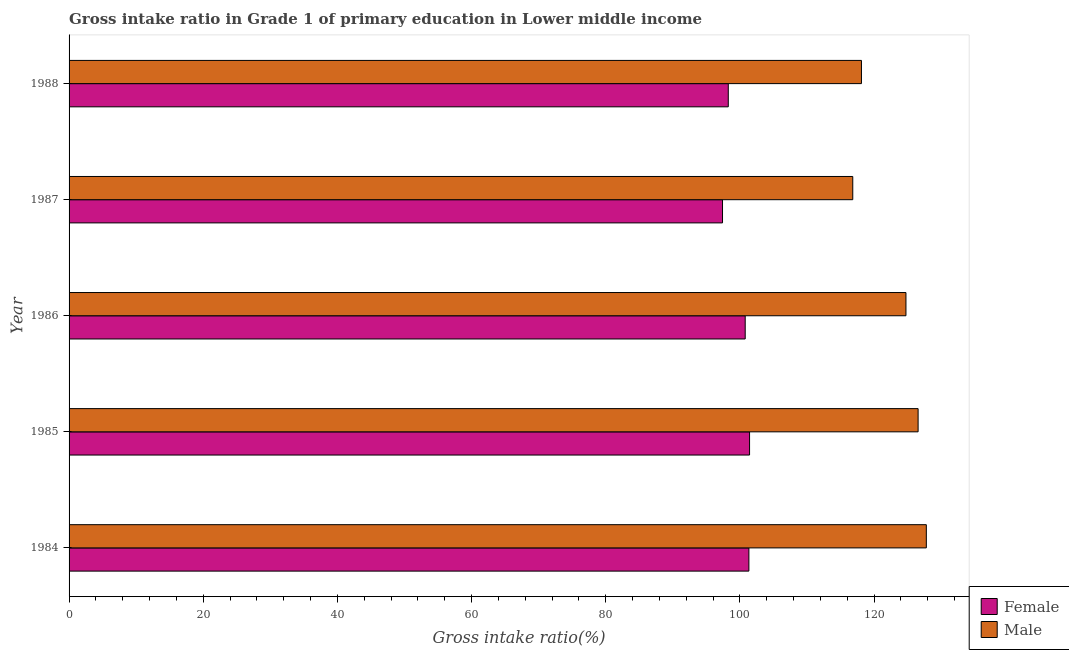How many groups of bars are there?
Keep it short and to the point. 5. Are the number of bars per tick equal to the number of legend labels?
Give a very brief answer. Yes. Are the number of bars on each tick of the Y-axis equal?
Your answer should be compact. Yes. How many bars are there on the 5th tick from the top?
Offer a terse response. 2. What is the gross intake ratio(male) in 1987?
Your answer should be compact. 116.81. Across all years, what is the maximum gross intake ratio(female)?
Make the answer very short. 101.43. Across all years, what is the minimum gross intake ratio(female)?
Your response must be concise. 97.4. In which year was the gross intake ratio(female) maximum?
Provide a succinct answer. 1985. What is the total gross intake ratio(male) in the graph?
Keep it short and to the point. 613.99. What is the difference between the gross intake ratio(female) in 1986 and that in 1987?
Your answer should be very brief. 3.38. What is the difference between the gross intake ratio(female) in 1985 and the gross intake ratio(male) in 1984?
Give a very brief answer. -26.35. What is the average gross intake ratio(male) per year?
Your response must be concise. 122.8. In the year 1988, what is the difference between the gross intake ratio(male) and gross intake ratio(female)?
Ensure brevity in your answer.  19.85. In how many years, is the gross intake ratio(female) greater than 100 %?
Your response must be concise. 3. What is the ratio of the gross intake ratio(male) in 1985 to that in 1987?
Provide a short and direct response. 1.08. Is the gross intake ratio(male) in 1984 less than that in 1988?
Provide a short and direct response. No. Is the difference between the gross intake ratio(female) in 1987 and 1988 greater than the difference between the gross intake ratio(male) in 1987 and 1988?
Provide a succinct answer. Yes. What is the difference between the highest and the second highest gross intake ratio(female)?
Provide a succinct answer. 0.1. What is the difference between the highest and the lowest gross intake ratio(female)?
Your answer should be very brief. 4.03. In how many years, is the gross intake ratio(female) greater than the average gross intake ratio(female) taken over all years?
Make the answer very short. 3. What does the 2nd bar from the top in 1986 represents?
Your response must be concise. Female. What does the 1st bar from the bottom in 1987 represents?
Ensure brevity in your answer.  Female. What is the difference between two consecutive major ticks on the X-axis?
Offer a terse response. 20. Where does the legend appear in the graph?
Give a very brief answer. Bottom right. What is the title of the graph?
Provide a succinct answer. Gross intake ratio in Grade 1 of primary education in Lower middle income. Does "Private credit bureau" appear as one of the legend labels in the graph?
Your answer should be compact. No. What is the label or title of the X-axis?
Offer a terse response. Gross intake ratio(%). What is the label or title of the Y-axis?
Keep it short and to the point. Year. What is the Gross intake ratio(%) in Female in 1984?
Give a very brief answer. 101.33. What is the Gross intake ratio(%) of Male in 1984?
Keep it short and to the point. 127.78. What is the Gross intake ratio(%) of Female in 1985?
Make the answer very short. 101.43. What is the Gross intake ratio(%) in Male in 1985?
Provide a short and direct response. 126.55. What is the Gross intake ratio(%) of Female in 1986?
Your answer should be very brief. 100.78. What is the Gross intake ratio(%) in Male in 1986?
Make the answer very short. 124.74. What is the Gross intake ratio(%) of Female in 1987?
Your answer should be compact. 97.4. What is the Gross intake ratio(%) in Male in 1987?
Your response must be concise. 116.81. What is the Gross intake ratio(%) of Female in 1988?
Offer a terse response. 98.26. What is the Gross intake ratio(%) in Male in 1988?
Give a very brief answer. 118.11. Across all years, what is the maximum Gross intake ratio(%) of Female?
Give a very brief answer. 101.43. Across all years, what is the maximum Gross intake ratio(%) of Male?
Offer a very short reply. 127.78. Across all years, what is the minimum Gross intake ratio(%) in Female?
Offer a terse response. 97.4. Across all years, what is the minimum Gross intake ratio(%) of Male?
Give a very brief answer. 116.81. What is the total Gross intake ratio(%) of Female in the graph?
Provide a succinct answer. 499.19. What is the total Gross intake ratio(%) in Male in the graph?
Offer a very short reply. 613.99. What is the difference between the Gross intake ratio(%) in Female in 1984 and that in 1985?
Your answer should be compact. -0.1. What is the difference between the Gross intake ratio(%) of Male in 1984 and that in 1985?
Give a very brief answer. 1.23. What is the difference between the Gross intake ratio(%) of Female in 1984 and that in 1986?
Ensure brevity in your answer.  0.55. What is the difference between the Gross intake ratio(%) in Male in 1984 and that in 1986?
Your response must be concise. 3.04. What is the difference between the Gross intake ratio(%) of Female in 1984 and that in 1987?
Provide a short and direct response. 3.93. What is the difference between the Gross intake ratio(%) in Male in 1984 and that in 1987?
Ensure brevity in your answer.  10.97. What is the difference between the Gross intake ratio(%) in Female in 1984 and that in 1988?
Provide a short and direct response. 3.07. What is the difference between the Gross intake ratio(%) in Male in 1984 and that in 1988?
Your response must be concise. 9.67. What is the difference between the Gross intake ratio(%) in Female in 1985 and that in 1986?
Provide a short and direct response. 0.65. What is the difference between the Gross intake ratio(%) of Male in 1985 and that in 1986?
Make the answer very short. 1.81. What is the difference between the Gross intake ratio(%) in Female in 1985 and that in 1987?
Provide a short and direct response. 4.03. What is the difference between the Gross intake ratio(%) of Male in 1985 and that in 1987?
Offer a very short reply. 9.74. What is the difference between the Gross intake ratio(%) in Female in 1985 and that in 1988?
Make the answer very short. 3.17. What is the difference between the Gross intake ratio(%) of Male in 1985 and that in 1988?
Offer a very short reply. 8.45. What is the difference between the Gross intake ratio(%) of Female in 1986 and that in 1987?
Ensure brevity in your answer.  3.38. What is the difference between the Gross intake ratio(%) of Male in 1986 and that in 1987?
Keep it short and to the point. 7.93. What is the difference between the Gross intake ratio(%) in Female in 1986 and that in 1988?
Provide a succinct answer. 2.52. What is the difference between the Gross intake ratio(%) of Male in 1986 and that in 1988?
Your answer should be very brief. 6.63. What is the difference between the Gross intake ratio(%) in Female in 1987 and that in 1988?
Give a very brief answer. -0.86. What is the difference between the Gross intake ratio(%) in Male in 1987 and that in 1988?
Provide a short and direct response. -1.29. What is the difference between the Gross intake ratio(%) in Female in 1984 and the Gross intake ratio(%) in Male in 1985?
Make the answer very short. -25.22. What is the difference between the Gross intake ratio(%) of Female in 1984 and the Gross intake ratio(%) of Male in 1986?
Ensure brevity in your answer.  -23.41. What is the difference between the Gross intake ratio(%) of Female in 1984 and the Gross intake ratio(%) of Male in 1987?
Offer a terse response. -15.48. What is the difference between the Gross intake ratio(%) in Female in 1984 and the Gross intake ratio(%) in Male in 1988?
Provide a succinct answer. -16.78. What is the difference between the Gross intake ratio(%) in Female in 1985 and the Gross intake ratio(%) in Male in 1986?
Your answer should be very brief. -23.31. What is the difference between the Gross intake ratio(%) in Female in 1985 and the Gross intake ratio(%) in Male in 1987?
Offer a terse response. -15.38. What is the difference between the Gross intake ratio(%) of Female in 1985 and the Gross intake ratio(%) of Male in 1988?
Your response must be concise. -16.68. What is the difference between the Gross intake ratio(%) of Female in 1986 and the Gross intake ratio(%) of Male in 1987?
Provide a succinct answer. -16.03. What is the difference between the Gross intake ratio(%) in Female in 1986 and the Gross intake ratio(%) in Male in 1988?
Offer a very short reply. -17.33. What is the difference between the Gross intake ratio(%) of Female in 1987 and the Gross intake ratio(%) of Male in 1988?
Offer a very short reply. -20.71. What is the average Gross intake ratio(%) in Female per year?
Give a very brief answer. 99.84. What is the average Gross intake ratio(%) of Male per year?
Offer a terse response. 122.8. In the year 1984, what is the difference between the Gross intake ratio(%) in Female and Gross intake ratio(%) in Male?
Provide a short and direct response. -26.45. In the year 1985, what is the difference between the Gross intake ratio(%) in Female and Gross intake ratio(%) in Male?
Your answer should be compact. -25.12. In the year 1986, what is the difference between the Gross intake ratio(%) of Female and Gross intake ratio(%) of Male?
Your response must be concise. -23.96. In the year 1987, what is the difference between the Gross intake ratio(%) of Female and Gross intake ratio(%) of Male?
Make the answer very short. -19.41. In the year 1988, what is the difference between the Gross intake ratio(%) of Female and Gross intake ratio(%) of Male?
Ensure brevity in your answer.  -19.85. What is the ratio of the Gross intake ratio(%) in Male in 1984 to that in 1985?
Keep it short and to the point. 1.01. What is the ratio of the Gross intake ratio(%) of Female in 1984 to that in 1986?
Your answer should be very brief. 1.01. What is the ratio of the Gross intake ratio(%) in Male in 1984 to that in 1986?
Give a very brief answer. 1.02. What is the ratio of the Gross intake ratio(%) in Female in 1984 to that in 1987?
Provide a short and direct response. 1.04. What is the ratio of the Gross intake ratio(%) in Male in 1984 to that in 1987?
Your response must be concise. 1.09. What is the ratio of the Gross intake ratio(%) of Female in 1984 to that in 1988?
Your response must be concise. 1.03. What is the ratio of the Gross intake ratio(%) in Male in 1984 to that in 1988?
Keep it short and to the point. 1.08. What is the ratio of the Gross intake ratio(%) in Female in 1985 to that in 1986?
Keep it short and to the point. 1.01. What is the ratio of the Gross intake ratio(%) of Male in 1985 to that in 1986?
Your answer should be very brief. 1.01. What is the ratio of the Gross intake ratio(%) in Female in 1985 to that in 1987?
Your response must be concise. 1.04. What is the ratio of the Gross intake ratio(%) in Male in 1985 to that in 1987?
Provide a short and direct response. 1.08. What is the ratio of the Gross intake ratio(%) in Female in 1985 to that in 1988?
Provide a short and direct response. 1.03. What is the ratio of the Gross intake ratio(%) of Male in 1985 to that in 1988?
Provide a succinct answer. 1.07. What is the ratio of the Gross intake ratio(%) of Female in 1986 to that in 1987?
Offer a very short reply. 1.03. What is the ratio of the Gross intake ratio(%) in Male in 1986 to that in 1987?
Offer a terse response. 1.07. What is the ratio of the Gross intake ratio(%) in Female in 1986 to that in 1988?
Make the answer very short. 1.03. What is the ratio of the Gross intake ratio(%) of Male in 1986 to that in 1988?
Ensure brevity in your answer.  1.06. What is the ratio of the Gross intake ratio(%) of Female in 1987 to that in 1988?
Offer a terse response. 0.99. What is the ratio of the Gross intake ratio(%) in Male in 1987 to that in 1988?
Offer a very short reply. 0.99. What is the difference between the highest and the second highest Gross intake ratio(%) of Female?
Provide a short and direct response. 0.1. What is the difference between the highest and the second highest Gross intake ratio(%) in Male?
Keep it short and to the point. 1.23. What is the difference between the highest and the lowest Gross intake ratio(%) of Female?
Offer a very short reply. 4.03. What is the difference between the highest and the lowest Gross intake ratio(%) of Male?
Provide a short and direct response. 10.97. 